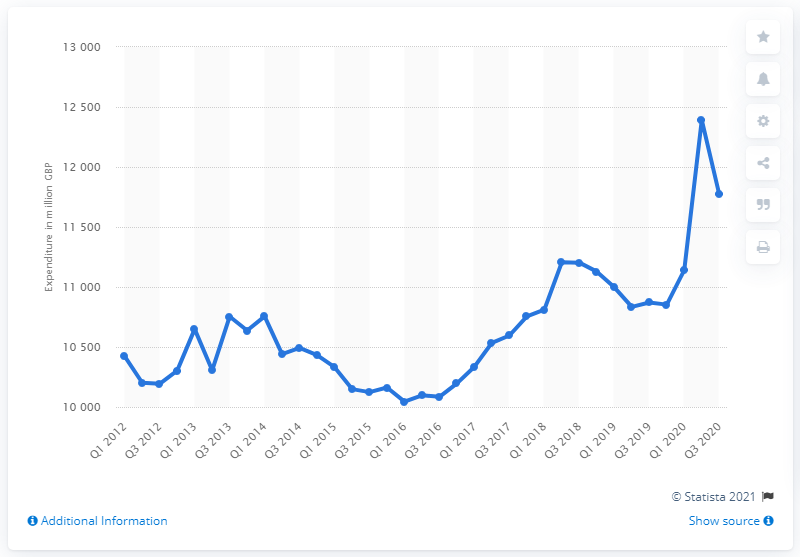Outline some significant characteristics in this image. In the third quarter of 2020, the consumer spent an estimated 117,720 on alcoholic beverages and tobacco. 